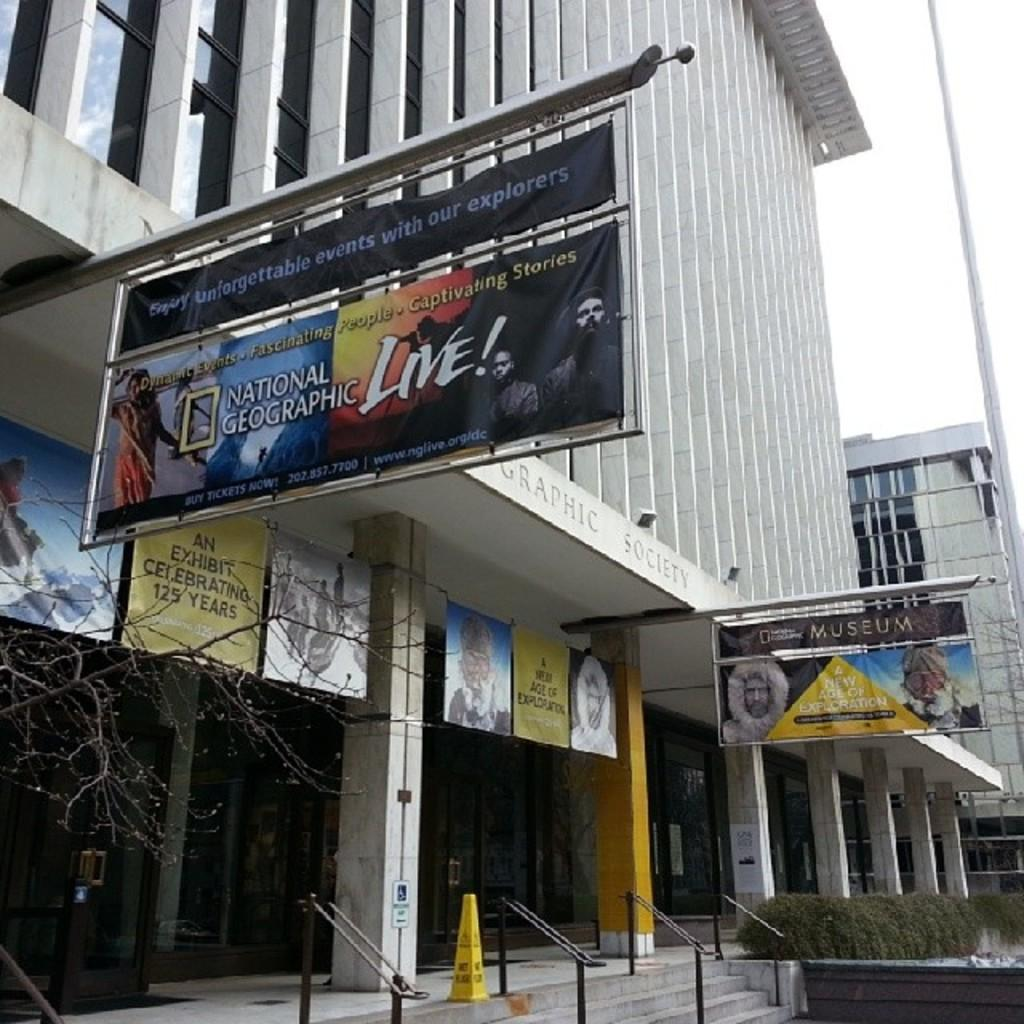<image>
Create a compact narrative representing the image presented. A building with an attached banner on a pole for National Geographic Live, 